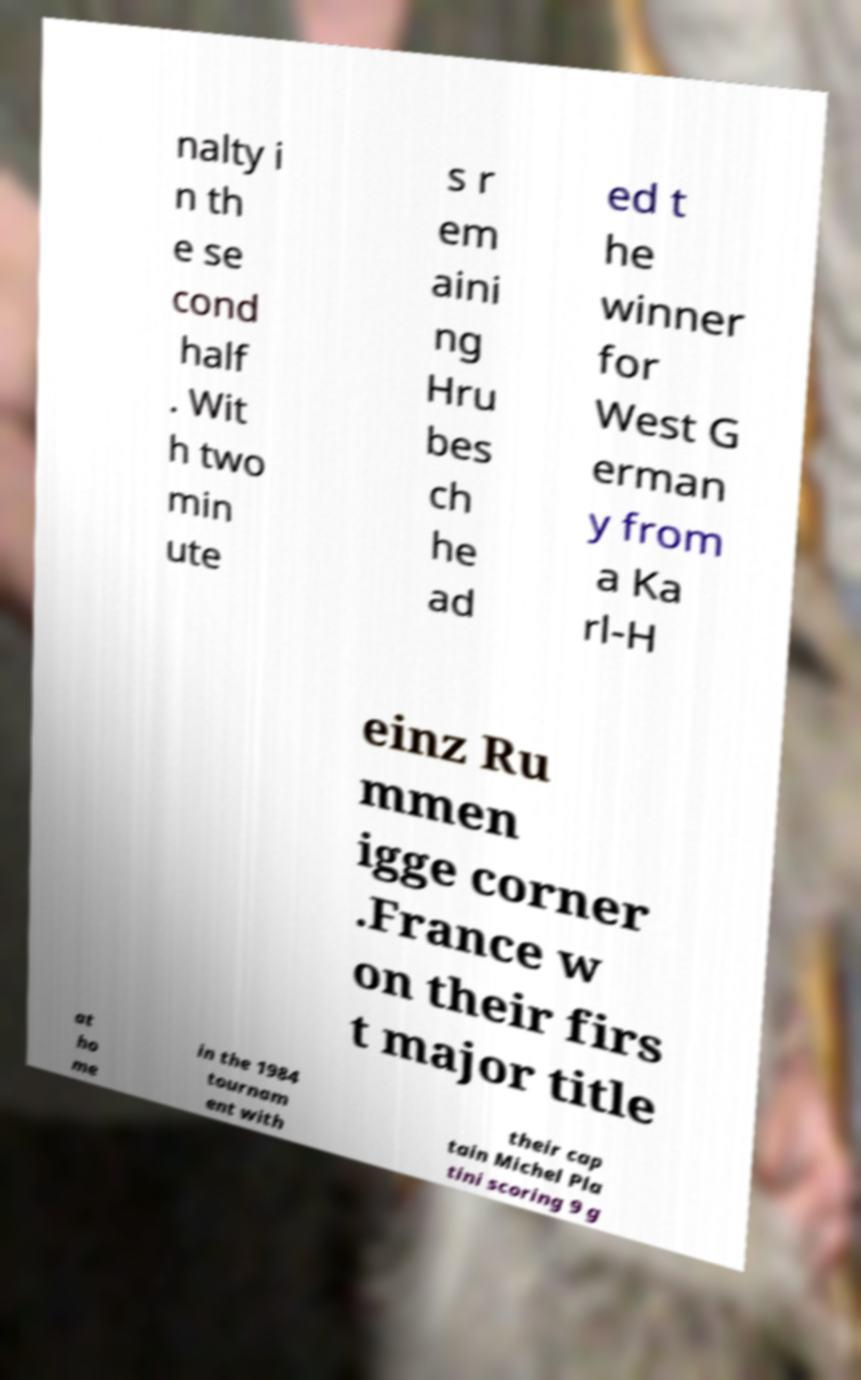There's text embedded in this image that I need extracted. Can you transcribe it verbatim? nalty i n th e se cond half . Wit h two min ute s r em aini ng Hru bes ch he ad ed t he winner for West G erman y from a Ka rl-H einz Ru mmen igge corner .France w on their firs t major title at ho me in the 1984 tournam ent with their cap tain Michel Pla tini scoring 9 g 